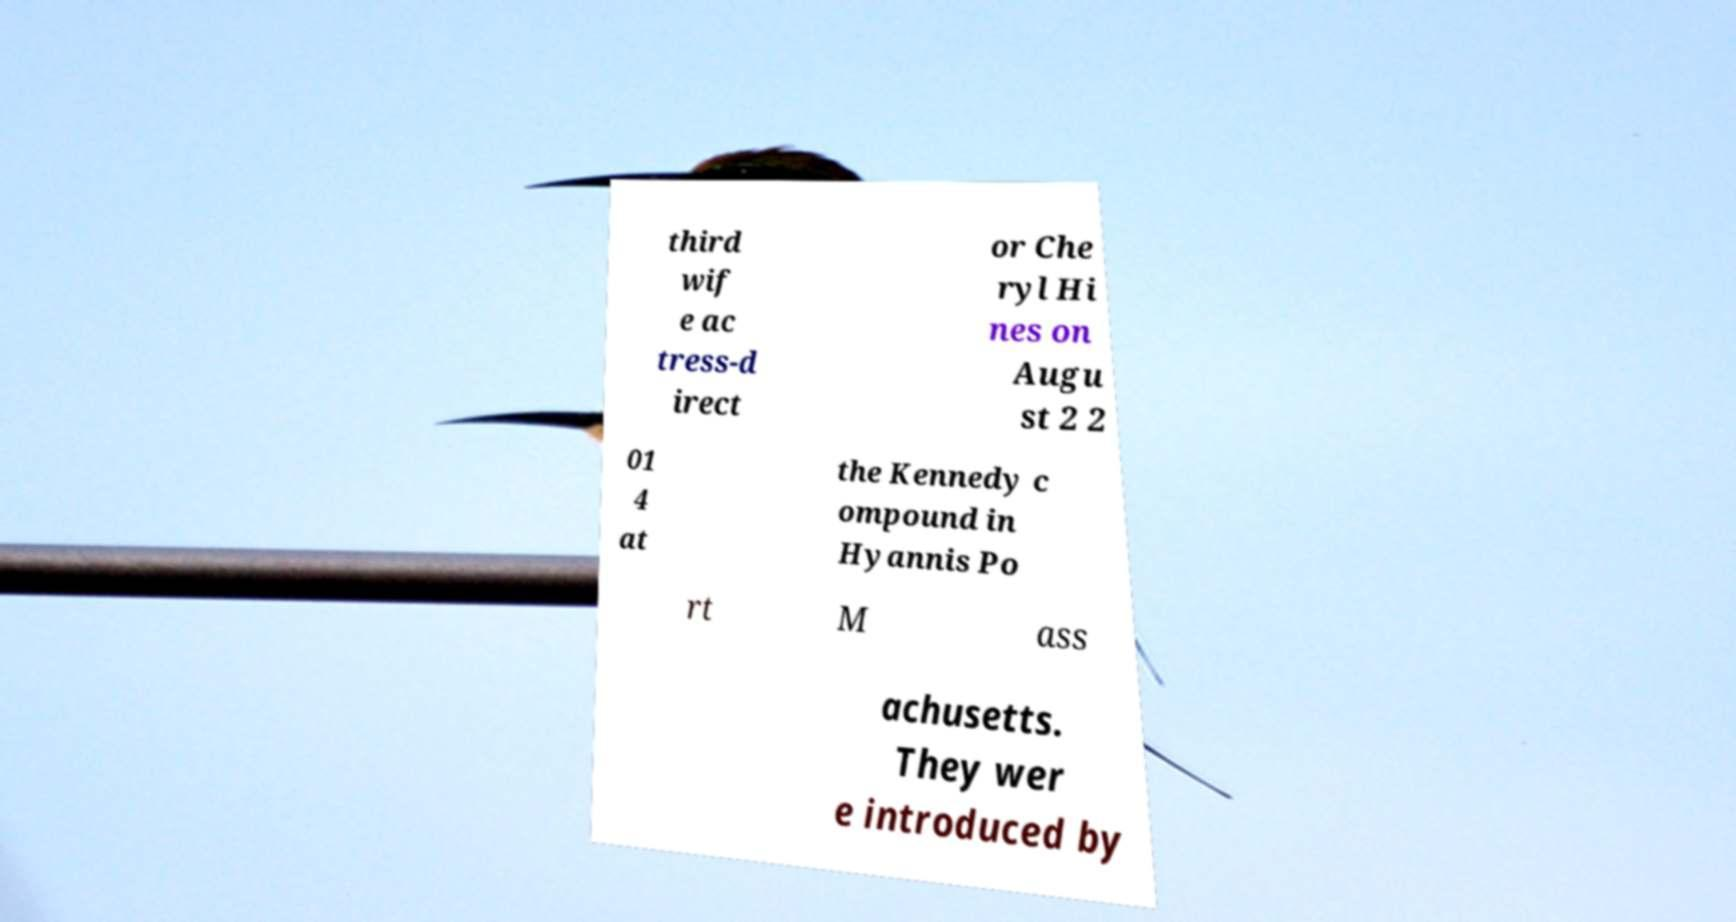Can you read and provide the text displayed in the image?This photo seems to have some interesting text. Can you extract and type it out for me? third wif e ac tress-d irect or Che ryl Hi nes on Augu st 2 2 01 4 at the Kennedy c ompound in Hyannis Po rt M ass achusetts. They wer e introduced by 